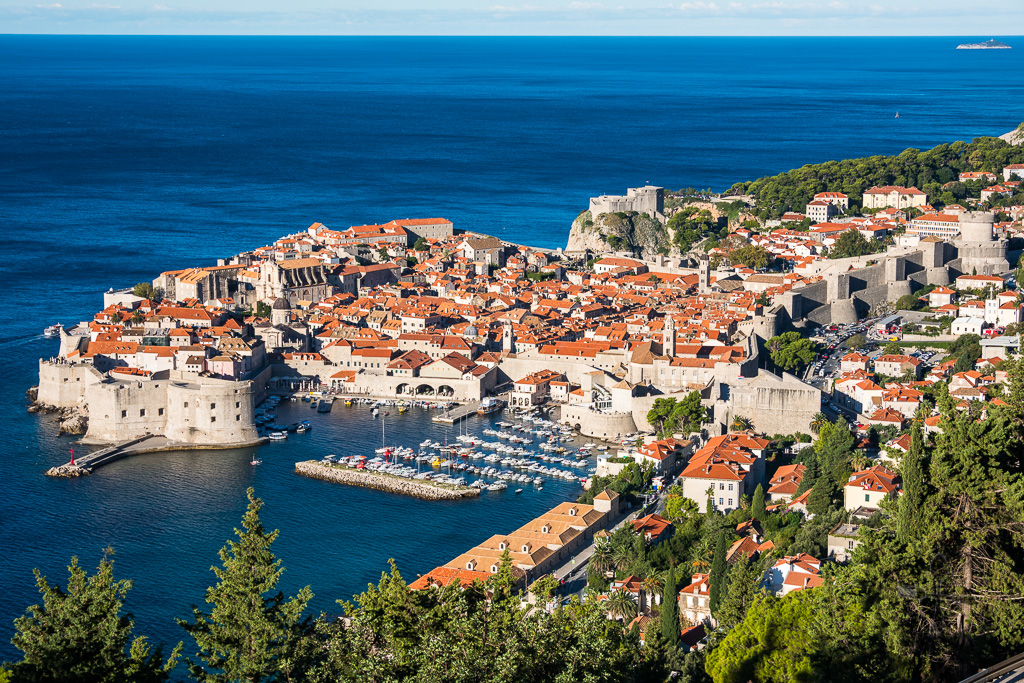What historical events have these city walls witnessed? The ancient city walls of Dubrovnik have seen numerous historic events over the centuries. Originally constructed in the 10th century and expanded in the 14th and 15th centuries, they have withstood numerous sieges and conflicts. Notably, Dubrovnik was a prominent maritime republic, the Republic of Ragusa, which maintained independence through skilled diplomacy amidst powerful neighbors like the Ottoman Empire and the Venetian Republic. The walls also bore witness to the earthquake of 1667, which almost destroyed the city. In more recent history, the walls suffered damage during the Croatian War of Independence in the early 1990s but have since been meticulously restored. 